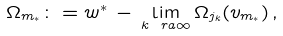Convert formula to latex. <formula><loc_0><loc_0><loc_500><loc_500>\Omega _ { m _ { * } } \colon = w ^ { * } \, - \, \lim _ { k \ r a \infty } \Omega _ { j _ { k } } ( v _ { m _ { * } } ) \, ,</formula> 